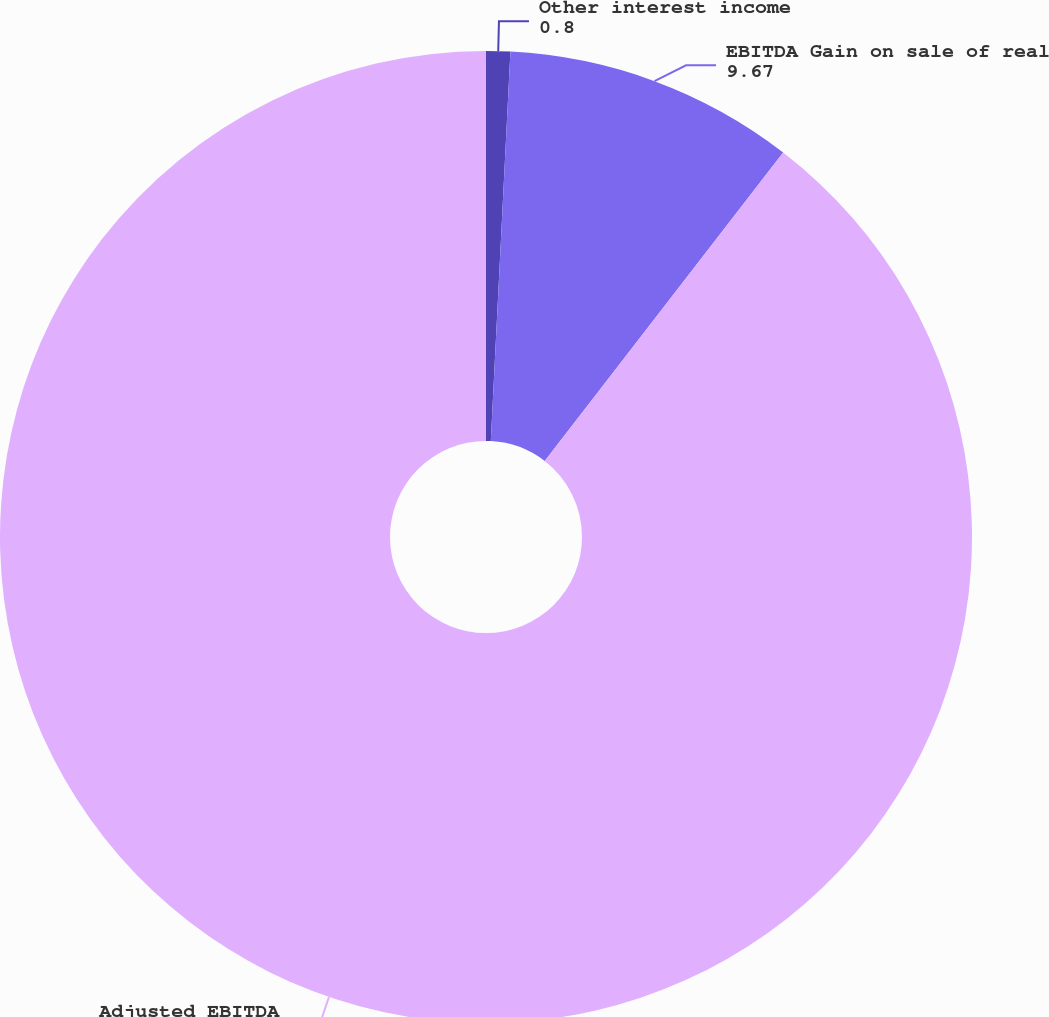Convert chart to OTSL. <chart><loc_0><loc_0><loc_500><loc_500><pie_chart><fcel>Other interest income<fcel>EBITDA Gain on sale of real<fcel>Adjusted EBITDA<nl><fcel>0.8%<fcel>9.67%<fcel>89.53%<nl></chart> 